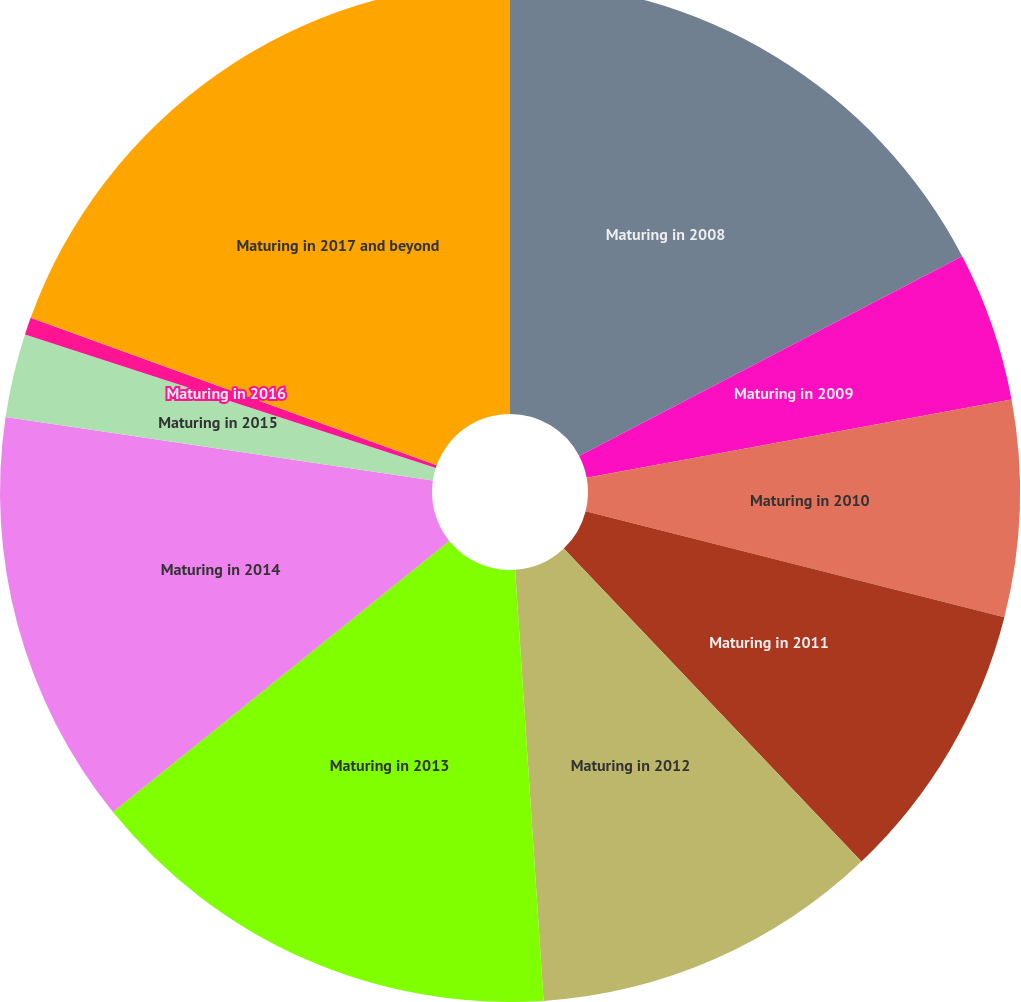<chart> <loc_0><loc_0><loc_500><loc_500><pie_chart><fcel>Maturing in 2008<fcel>Maturing in 2009<fcel>Maturing in 2010<fcel>Maturing in 2011<fcel>Maturing in 2012<fcel>Maturing in 2013<fcel>Maturing in 2014<fcel>Maturing in 2015<fcel>Maturing in 2016<fcel>Maturing in 2017 and beyond<nl><fcel>17.35%<fcel>4.75%<fcel>6.85%<fcel>8.95%<fcel>11.05%<fcel>15.25%<fcel>13.15%<fcel>2.65%<fcel>0.55%<fcel>19.45%<nl></chart> 